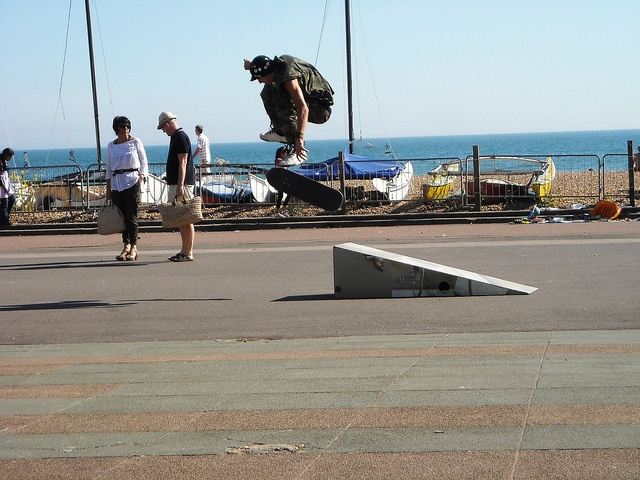Describe the objects in this image and their specific colors. I can see people in lightblue, black, gray, darkgray, and maroon tones, people in lightblue, black, gray, and white tones, people in lightblue, black, maroon, gray, and lightgray tones, skateboard in lightblue, black, gray, and darkgray tones, and boat in lightblue, gray, navy, and blue tones in this image. 